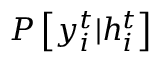<formula> <loc_0><loc_0><loc_500><loc_500>P \left [ y _ { i } ^ { t } | h _ { i } ^ { t } \right ]</formula> 